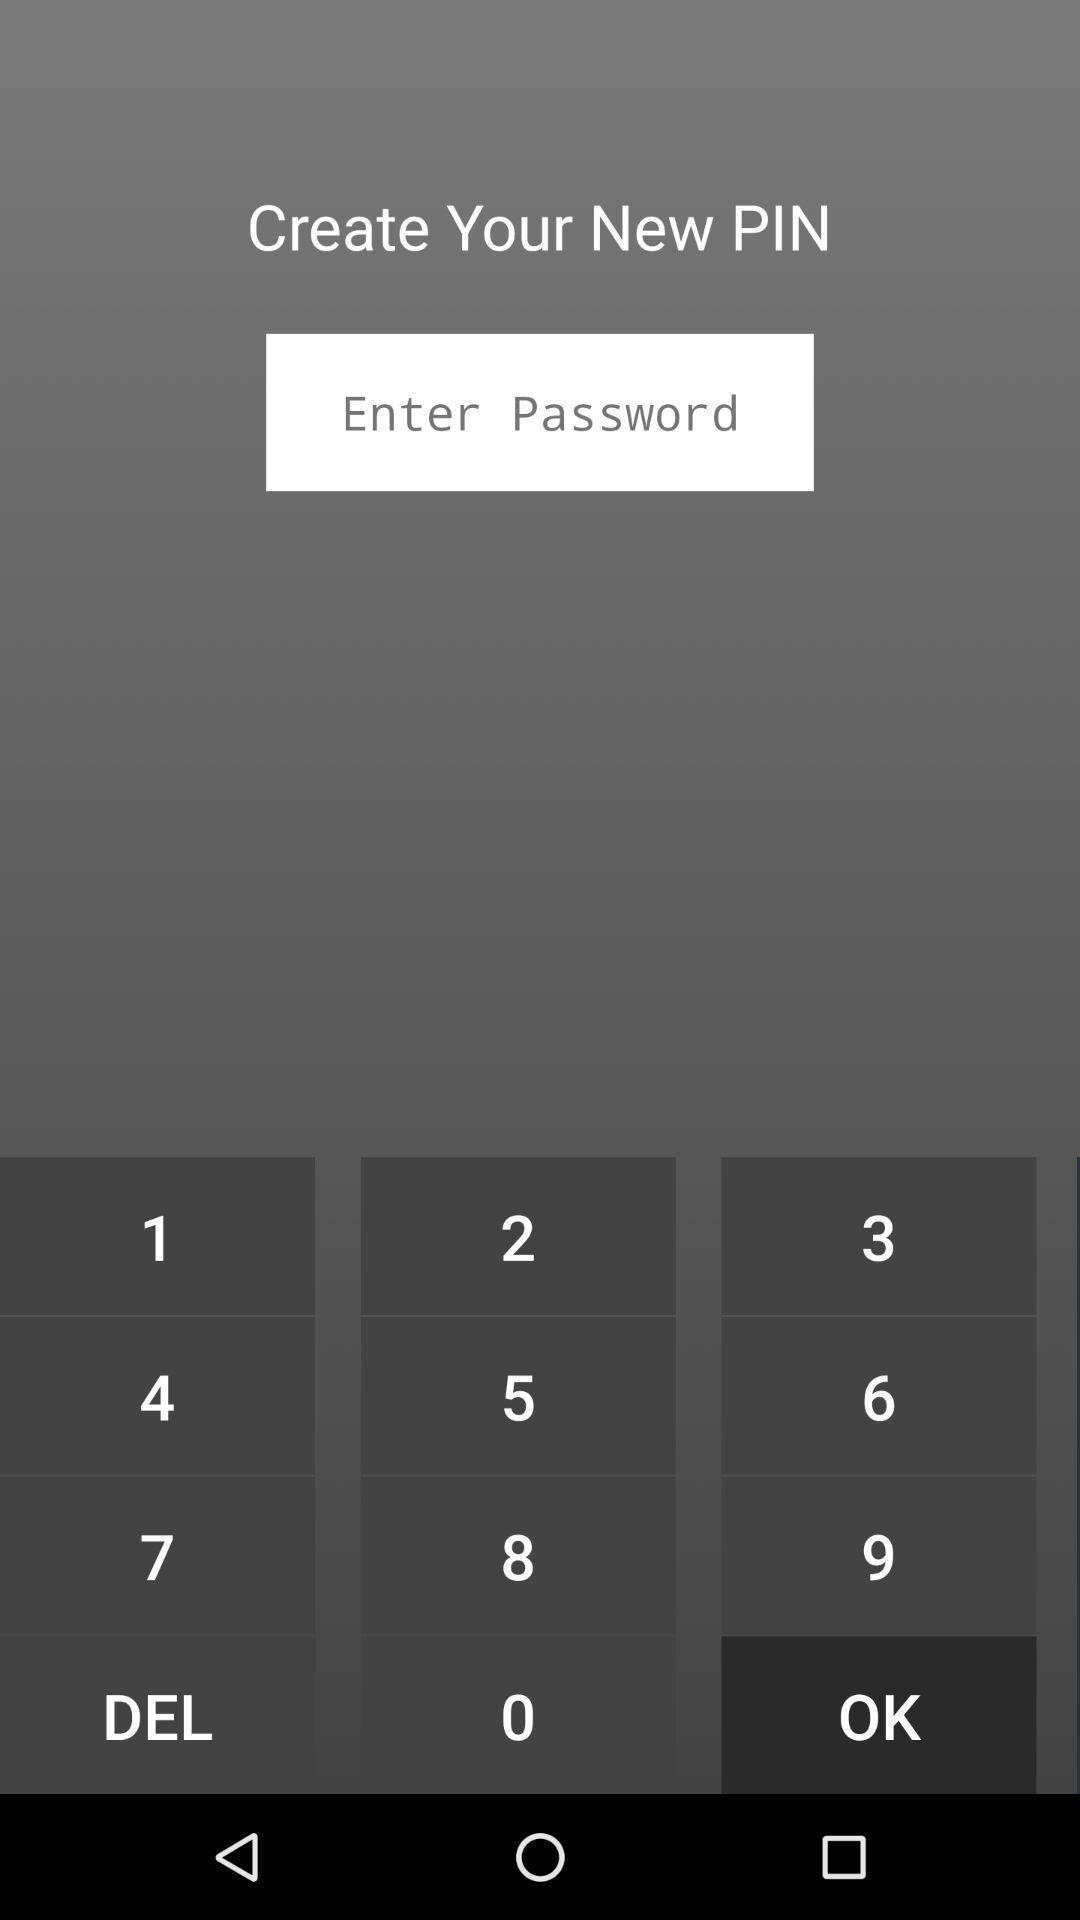Summarize the information in this screenshot. Screen displaying the keypad to enter pin. 